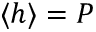Convert formula to latex. <formula><loc_0><loc_0><loc_500><loc_500>\langle h \rangle = P</formula> 